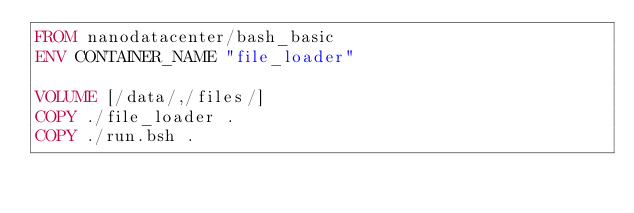<code> <loc_0><loc_0><loc_500><loc_500><_Dockerfile_>FROM nanodatacenter/bash_basic 
ENV CONTAINER_NAME "file_loader" 
 
VOLUME [/data/,/files/] 
COPY ./file_loader .
COPY ./run.bsh .


</code> 